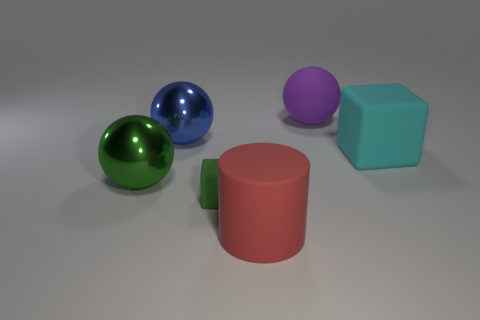What size is the green shiny thing that is the same shape as the blue thing?
Give a very brief answer. Large. The rubber thing that is in front of the matte block in front of the cyan rubber block is what shape?
Your answer should be very brief. Cylinder. What number of brown objects are either large matte objects or matte objects?
Provide a succinct answer. 0. What color is the big cube?
Ensure brevity in your answer.  Cyan. Is the purple object the same size as the rubber cylinder?
Offer a very short reply. Yes. Is there anything else that has the same shape as the large cyan rubber object?
Offer a very short reply. Yes. Is the cylinder made of the same material as the cube that is to the right of the purple matte sphere?
Your response must be concise. Yes. There is a matte object behind the blue metallic object; does it have the same color as the large cylinder?
Provide a succinct answer. No. What number of things are left of the red rubber thing and on the right side of the big red cylinder?
Your answer should be very brief. 0. What number of other objects are there of the same material as the small green object?
Your answer should be compact. 3. 